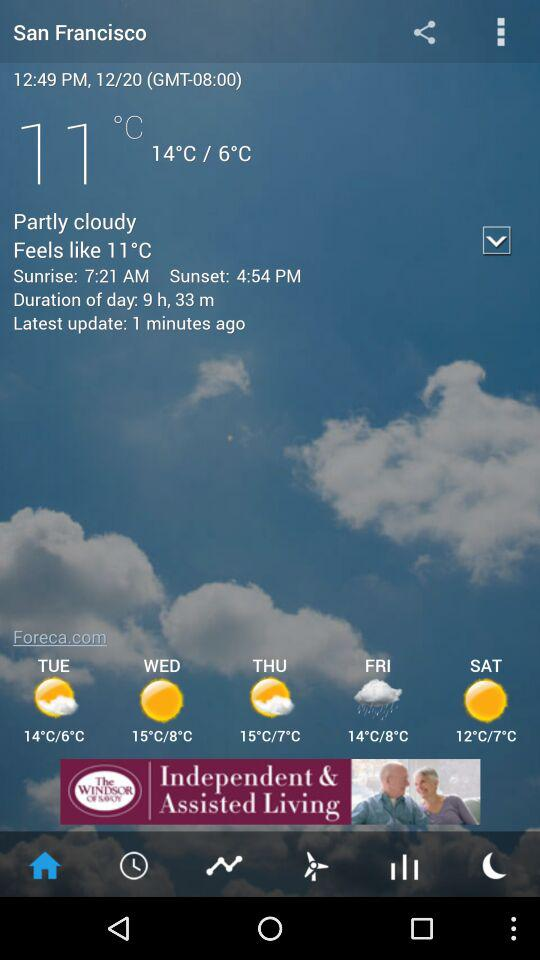Please describe the weather forecast for the coming days. The forecast for San Francisco in the coming days suggests mostly sunny weather with temperatures ranging from lows of 6°C to 8°C and highs of 14°C to 15°C. 